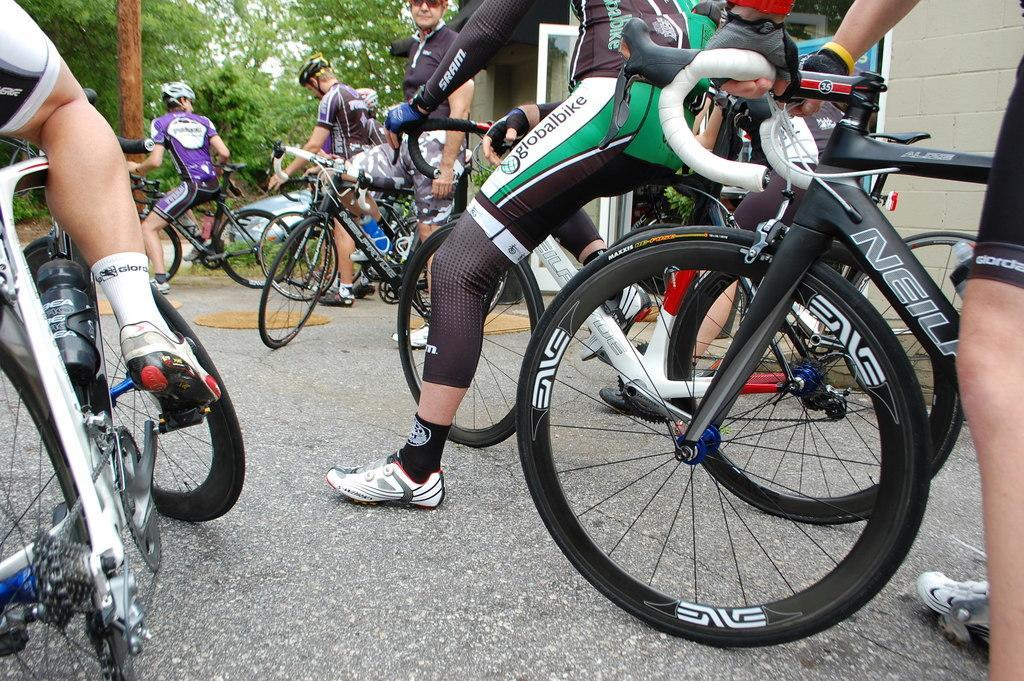Could you give a brief overview of what you see in this image? In this image we can see people riding bicycles. At the bottom of the image there is road. In the background of the image there are trees. 